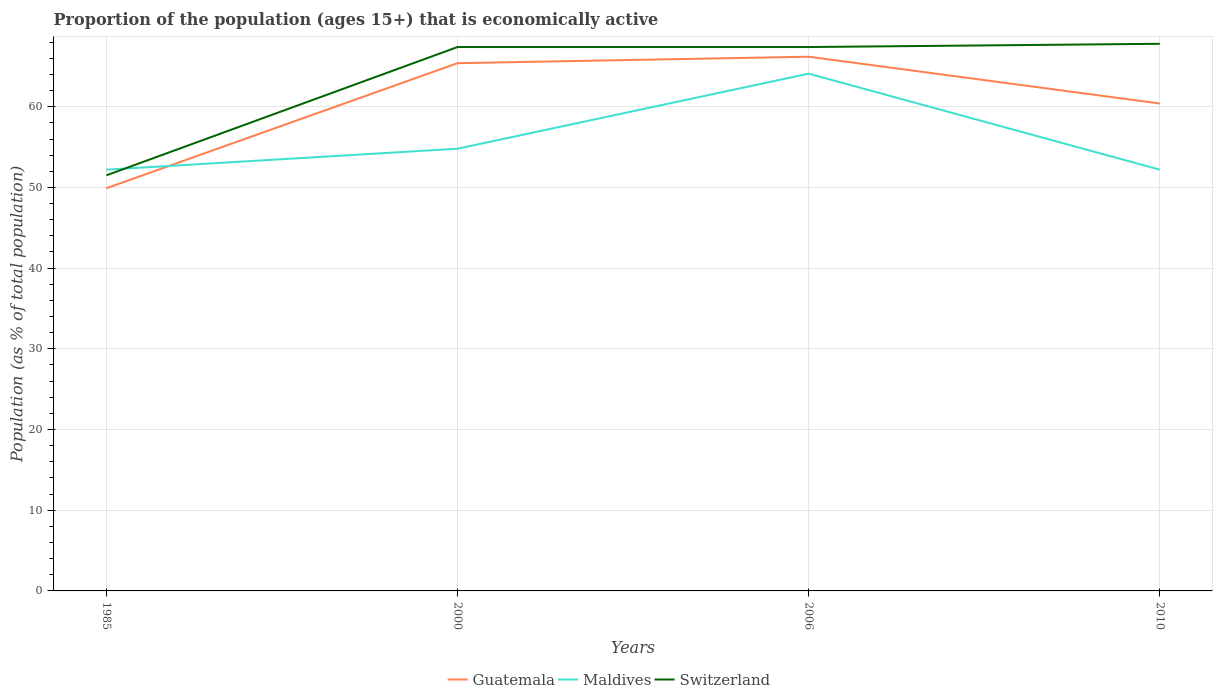Across all years, what is the maximum proportion of the population that is economically active in Switzerland?
Offer a very short reply. 51.5. In which year was the proportion of the population that is economically active in Switzerland maximum?
Your answer should be very brief. 1985. What is the total proportion of the population that is economically active in Maldives in the graph?
Make the answer very short. -2.6. What is the difference between the highest and the second highest proportion of the population that is economically active in Guatemala?
Your answer should be compact. 16.3. What is the difference between the highest and the lowest proportion of the population that is economically active in Maldives?
Provide a succinct answer. 1. How many years are there in the graph?
Ensure brevity in your answer.  4. What is the difference between two consecutive major ticks on the Y-axis?
Your answer should be very brief. 10. Does the graph contain any zero values?
Provide a succinct answer. No. Where does the legend appear in the graph?
Your response must be concise. Bottom center. What is the title of the graph?
Offer a very short reply. Proportion of the population (ages 15+) that is economically active. What is the label or title of the Y-axis?
Offer a very short reply. Population (as % of total population). What is the Population (as % of total population) in Guatemala in 1985?
Ensure brevity in your answer.  49.9. What is the Population (as % of total population) in Maldives in 1985?
Keep it short and to the point. 52.2. What is the Population (as % of total population) in Switzerland in 1985?
Your answer should be very brief. 51.5. What is the Population (as % of total population) in Guatemala in 2000?
Your answer should be very brief. 65.4. What is the Population (as % of total population) in Maldives in 2000?
Provide a short and direct response. 54.8. What is the Population (as % of total population) of Switzerland in 2000?
Provide a succinct answer. 67.4. What is the Population (as % of total population) in Guatemala in 2006?
Keep it short and to the point. 66.2. What is the Population (as % of total population) in Maldives in 2006?
Keep it short and to the point. 64.1. What is the Population (as % of total population) in Switzerland in 2006?
Your answer should be compact. 67.4. What is the Population (as % of total population) in Guatemala in 2010?
Offer a very short reply. 60.4. What is the Population (as % of total population) in Maldives in 2010?
Provide a short and direct response. 52.2. What is the Population (as % of total population) in Switzerland in 2010?
Keep it short and to the point. 67.8. Across all years, what is the maximum Population (as % of total population) in Guatemala?
Ensure brevity in your answer.  66.2. Across all years, what is the maximum Population (as % of total population) in Maldives?
Your answer should be very brief. 64.1. Across all years, what is the maximum Population (as % of total population) in Switzerland?
Offer a terse response. 67.8. Across all years, what is the minimum Population (as % of total population) of Guatemala?
Keep it short and to the point. 49.9. Across all years, what is the minimum Population (as % of total population) of Maldives?
Provide a succinct answer. 52.2. Across all years, what is the minimum Population (as % of total population) in Switzerland?
Provide a short and direct response. 51.5. What is the total Population (as % of total population) of Guatemala in the graph?
Provide a short and direct response. 241.9. What is the total Population (as % of total population) in Maldives in the graph?
Your answer should be compact. 223.3. What is the total Population (as % of total population) in Switzerland in the graph?
Your answer should be very brief. 254.1. What is the difference between the Population (as % of total population) in Guatemala in 1985 and that in 2000?
Your response must be concise. -15.5. What is the difference between the Population (as % of total population) of Switzerland in 1985 and that in 2000?
Provide a short and direct response. -15.9. What is the difference between the Population (as % of total population) of Guatemala in 1985 and that in 2006?
Make the answer very short. -16.3. What is the difference between the Population (as % of total population) in Maldives in 1985 and that in 2006?
Provide a succinct answer. -11.9. What is the difference between the Population (as % of total population) in Switzerland in 1985 and that in 2006?
Offer a very short reply. -15.9. What is the difference between the Population (as % of total population) of Switzerland in 1985 and that in 2010?
Provide a short and direct response. -16.3. What is the difference between the Population (as % of total population) of Switzerland in 2000 and that in 2010?
Give a very brief answer. -0.4. What is the difference between the Population (as % of total population) in Maldives in 2006 and that in 2010?
Make the answer very short. 11.9. What is the difference between the Population (as % of total population) of Guatemala in 1985 and the Population (as % of total population) of Maldives in 2000?
Provide a short and direct response. -4.9. What is the difference between the Population (as % of total population) in Guatemala in 1985 and the Population (as % of total population) in Switzerland in 2000?
Your answer should be compact. -17.5. What is the difference between the Population (as % of total population) of Maldives in 1985 and the Population (as % of total population) of Switzerland in 2000?
Ensure brevity in your answer.  -15.2. What is the difference between the Population (as % of total population) of Guatemala in 1985 and the Population (as % of total population) of Switzerland in 2006?
Your response must be concise. -17.5. What is the difference between the Population (as % of total population) of Maldives in 1985 and the Population (as % of total population) of Switzerland in 2006?
Your answer should be very brief. -15.2. What is the difference between the Population (as % of total population) of Guatemala in 1985 and the Population (as % of total population) of Maldives in 2010?
Give a very brief answer. -2.3. What is the difference between the Population (as % of total population) of Guatemala in 1985 and the Population (as % of total population) of Switzerland in 2010?
Your answer should be very brief. -17.9. What is the difference between the Population (as % of total population) in Maldives in 1985 and the Population (as % of total population) in Switzerland in 2010?
Your answer should be very brief. -15.6. What is the difference between the Population (as % of total population) of Guatemala in 2000 and the Population (as % of total population) of Switzerland in 2006?
Your answer should be compact. -2. What is the difference between the Population (as % of total population) of Guatemala in 2000 and the Population (as % of total population) of Maldives in 2010?
Provide a short and direct response. 13.2. What is the difference between the Population (as % of total population) of Maldives in 2000 and the Population (as % of total population) of Switzerland in 2010?
Your answer should be compact. -13. What is the difference between the Population (as % of total population) in Guatemala in 2006 and the Population (as % of total population) in Maldives in 2010?
Make the answer very short. 14. What is the difference between the Population (as % of total population) in Maldives in 2006 and the Population (as % of total population) in Switzerland in 2010?
Offer a terse response. -3.7. What is the average Population (as % of total population) in Guatemala per year?
Ensure brevity in your answer.  60.48. What is the average Population (as % of total population) of Maldives per year?
Ensure brevity in your answer.  55.83. What is the average Population (as % of total population) in Switzerland per year?
Ensure brevity in your answer.  63.52. In the year 1985, what is the difference between the Population (as % of total population) in Guatemala and Population (as % of total population) in Maldives?
Provide a succinct answer. -2.3. In the year 2000, what is the difference between the Population (as % of total population) in Guatemala and Population (as % of total population) in Maldives?
Your answer should be very brief. 10.6. In the year 2000, what is the difference between the Population (as % of total population) in Maldives and Population (as % of total population) in Switzerland?
Provide a short and direct response. -12.6. In the year 2010, what is the difference between the Population (as % of total population) in Guatemala and Population (as % of total population) in Maldives?
Your answer should be very brief. 8.2. In the year 2010, what is the difference between the Population (as % of total population) in Maldives and Population (as % of total population) in Switzerland?
Provide a short and direct response. -15.6. What is the ratio of the Population (as % of total population) in Guatemala in 1985 to that in 2000?
Provide a succinct answer. 0.76. What is the ratio of the Population (as % of total population) of Maldives in 1985 to that in 2000?
Provide a short and direct response. 0.95. What is the ratio of the Population (as % of total population) in Switzerland in 1985 to that in 2000?
Make the answer very short. 0.76. What is the ratio of the Population (as % of total population) in Guatemala in 1985 to that in 2006?
Provide a succinct answer. 0.75. What is the ratio of the Population (as % of total population) in Maldives in 1985 to that in 2006?
Make the answer very short. 0.81. What is the ratio of the Population (as % of total population) in Switzerland in 1985 to that in 2006?
Keep it short and to the point. 0.76. What is the ratio of the Population (as % of total population) in Guatemala in 1985 to that in 2010?
Provide a succinct answer. 0.83. What is the ratio of the Population (as % of total population) of Maldives in 1985 to that in 2010?
Offer a terse response. 1. What is the ratio of the Population (as % of total population) of Switzerland in 1985 to that in 2010?
Your answer should be compact. 0.76. What is the ratio of the Population (as % of total population) in Guatemala in 2000 to that in 2006?
Ensure brevity in your answer.  0.99. What is the ratio of the Population (as % of total population) in Maldives in 2000 to that in 2006?
Your response must be concise. 0.85. What is the ratio of the Population (as % of total population) of Switzerland in 2000 to that in 2006?
Your answer should be compact. 1. What is the ratio of the Population (as % of total population) in Guatemala in 2000 to that in 2010?
Offer a terse response. 1.08. What is the ratio of the Population (as % of total population) in Maldives in 2000 to that in 2010?
Your answer should be compact. 1.05. What is the ratio of the Population (as % of total population) of Guatemala in 2006 to that in 2010?
Give a very brief answer. 1.1. What is the ratio of the Population (as % of total population) in Maldives in 2006 to that in 2010?
Your answer should be very brief. 1.23. What is the difference between the highest and the second highest Population (as % of total population) in Guatemala?
Ensure brevity in your answer.  0.8. What is the difference between the highest and the second highest Population (as % of total population) of Maldives?
Provide a succinct answer. 9.3. What is the difference between the highest and the second highest Population (as % of total population) in Switzerland?
Provide a short and direct response. 0.4. What is the difference between the highest and the lowest Population (as % of total population) in Guatemala?
Offer a terse response. 16.3. What is the difference between the highest and the lowest Population (as % of total population) of Maldives?
Offer a very short reply. 11.9. 